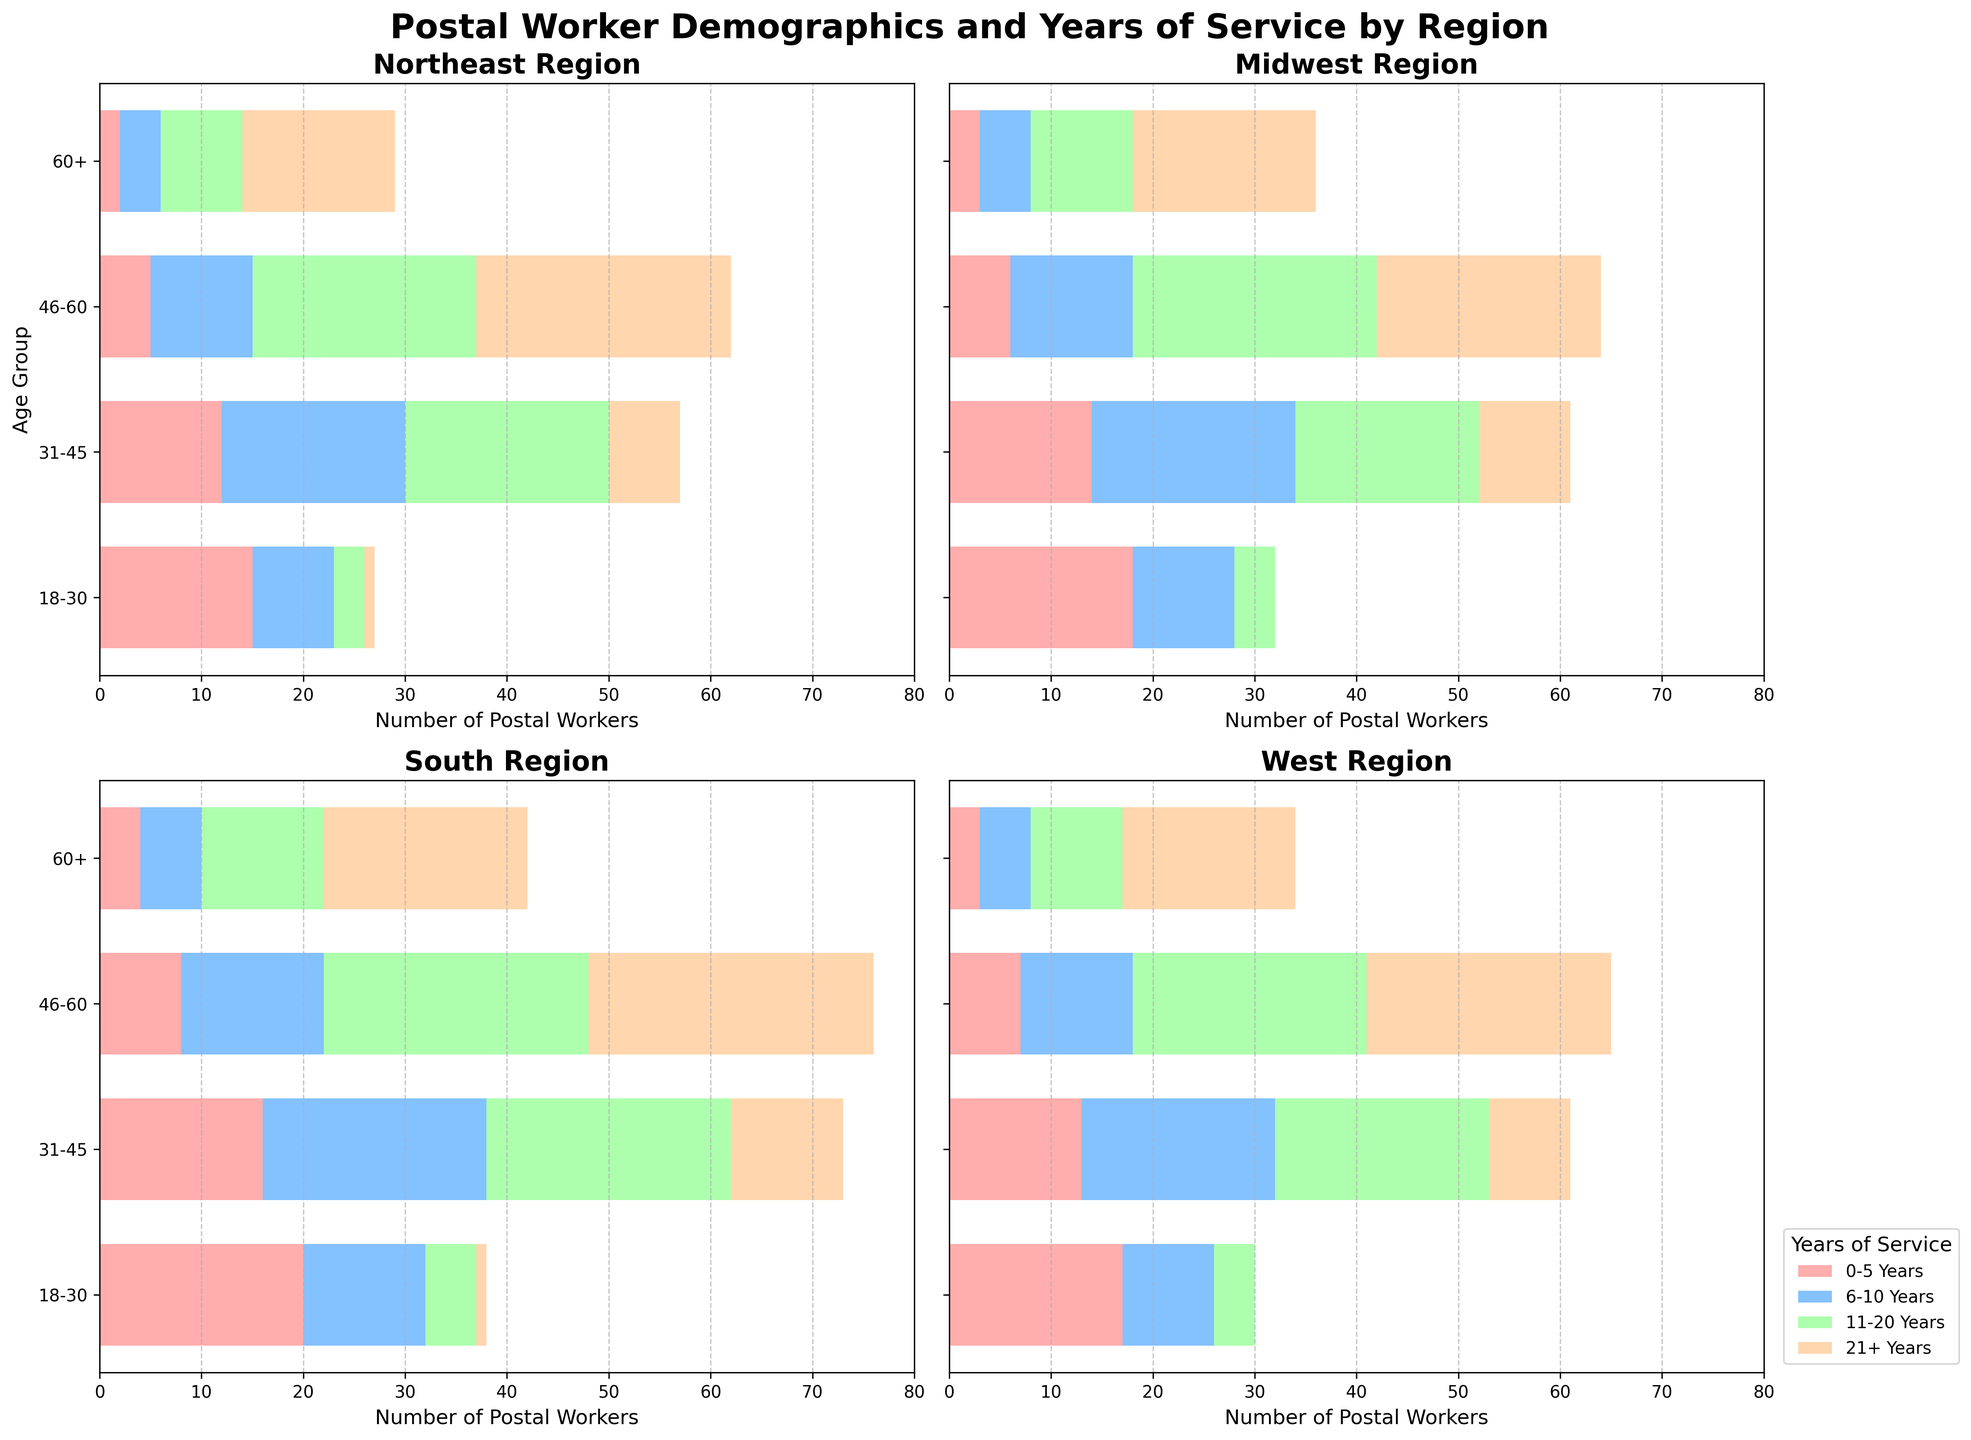What's the title of the figure? The title of the figure is typically displayed at the top of the chart. In this case, it should be bold and prominent.
Answer: Postal Worker Demographics and Years of Service by Region Which region has the highest number of postal workers aged 18-30 with 0-5 years of service? Look at the first bar (0-5 Years) in the 18-30 age group across all regions. The region with the longest bar will have the highest number.
Answer: South In the Northeast region, how many postal workers are in the 46-60 age group with 21+ years of service? Refer to the bar corresponding to the 21+ years category in the 46-60 age group within the Northeast subplot.
Answer: 25 Comparing the Midwest and West regions, which one has more postal workers aged 60+ with 11-20 years of service? Identify the 11-20 years bar for the age group 60+ in both the Midwest and West regions. Compare their lengths or values.
Answer: West What is the total number of postal workers aged 31-45 in the South region? Sum up all the bars in the 31-45 age group within the South region subplot: 16 (0-5 years) + 22 (6-10 years) + 24 (11-20 years) + 11 (21+ years).
Answer: 73 Which age group has the least number of postal workers in the Northeast region? Compare the total height of the bars for each age group in the Northeast region and identify the smallest one.
Answer: 18-30 How does the number of postal workers with 11-20 years of service compare between the South and Northeast regions for the age group 31-45? Compare the 11-20 years bar within the 31-45 age group between the South and Northeast subplots.
Answer: South has more Which region shows the highest number of postal workers aged 60+ with 21+ years of service? Look at the bar corresponding to the 21+ years category in the 60+ age group across all regions.
Answer: South What is the pattern of years of service for postal workers aged 46-60 in the Midwest region? Observe the lengths of the bars for each years-of-service category within the 46-60 age group in the Midwest region.
Answer: Increasing trend with 21+ years being the highest Can you identify any regions where young postal workers (18-30) tend to have longer years of service (11-20 years and 21+ years)? Look for significant bar lengths in the 11-20 years and 21+ years categories for the 18-30 age group across all regions.
Answer: No such tendency 